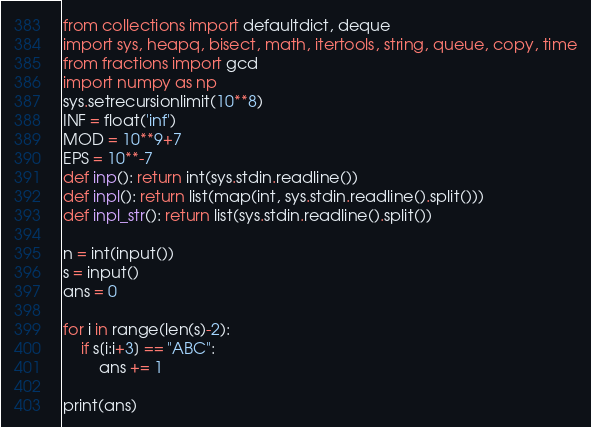<code> <loc_0><loc_0><loc_500><loc_500><_Python_>from collections import defaultdict, deque
import sys, heapq, bisect, math, itertools, string, queue, copy, time
from fractions import gcd
import numpy as np
sys.setrecursionlimit(10**8)
INF = float('inf')
MOD = 10**9+7
EPS = 10**-7
def inp(): return int(sys.stdin.readline())
def inpl(): return list(map(int, sys.stdin.readline().split()))
def inpl_str(): return list(sys.stdin.readline().split())

n = int(input())
s = input()
ans = 0

for i in range(len(s)-2):
    if s[i:i+3] == "ABC":
        ans += 1

print(ans)</code> 